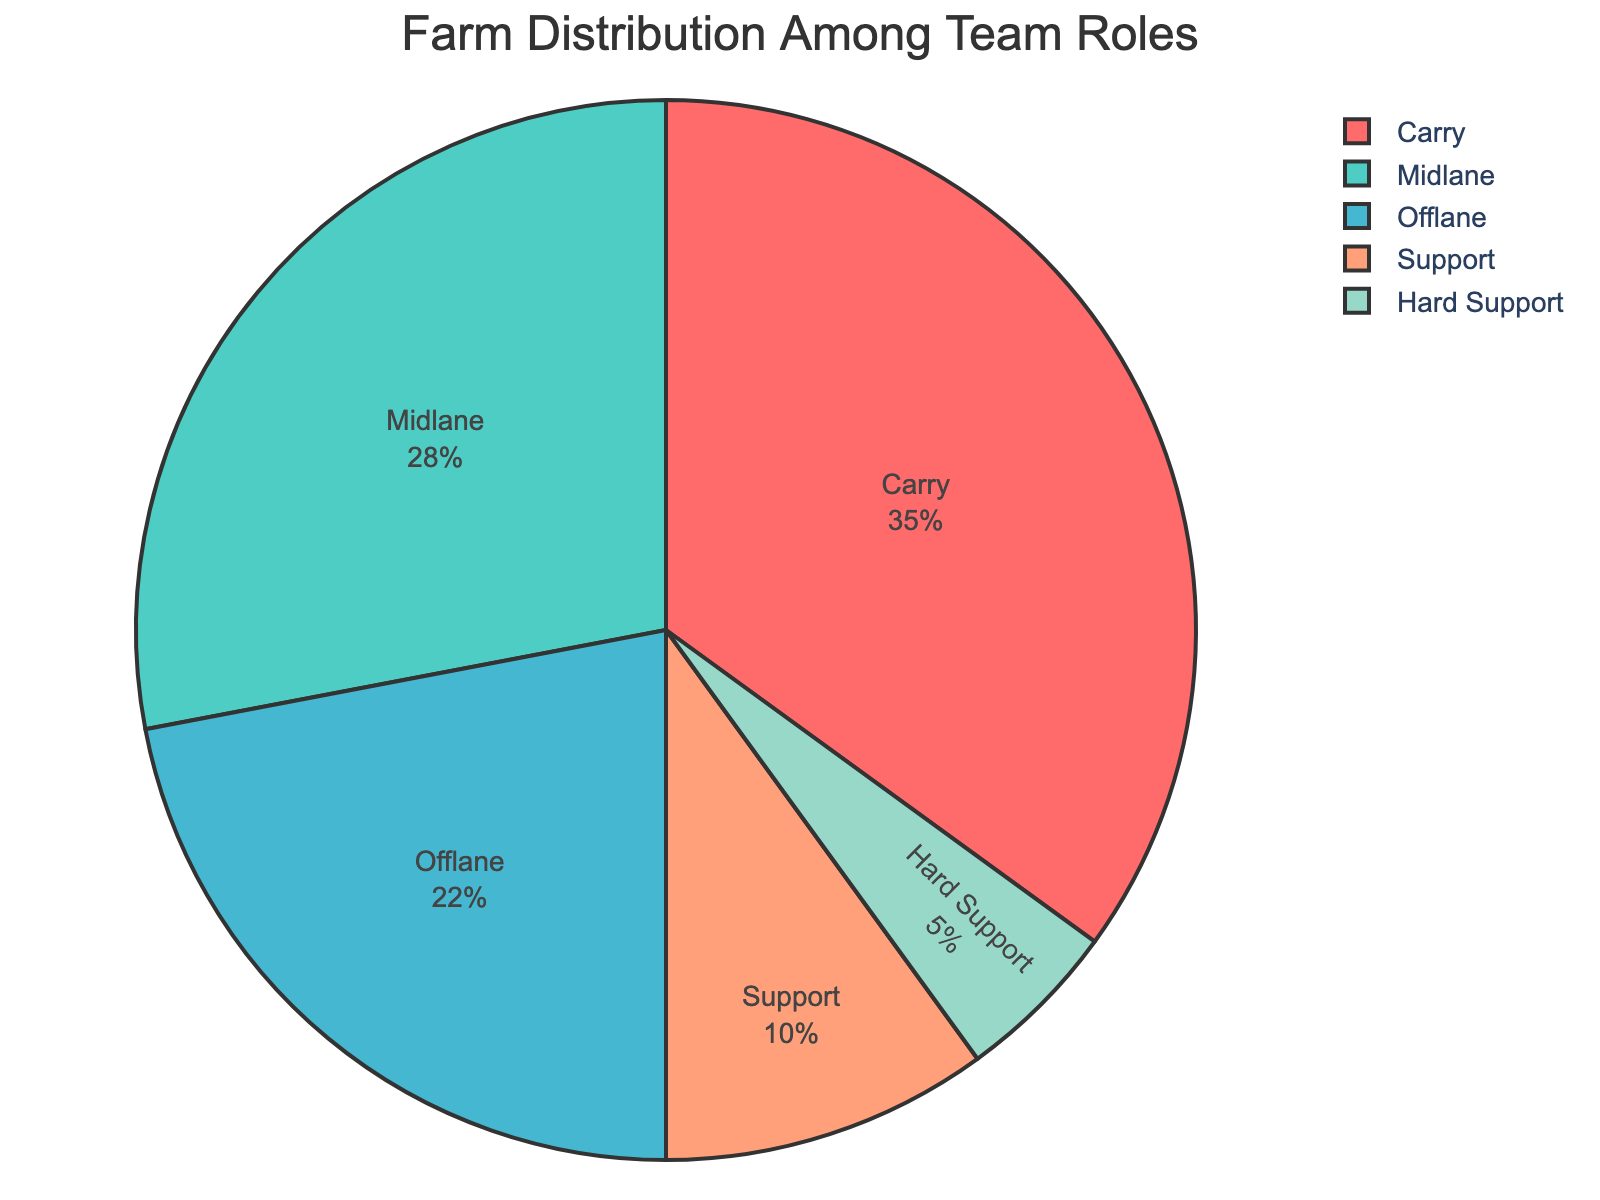What role has the highest farm percentage? By visually inspecting the pie chart, we can see the largest sector corresponds to the role with the highest farm percentage.
Answer: Carry How much more farm percentage does the Carry have compared to the Midlane? The Carry has 35% and the Midlane has 28%. Subtracting these values gives 35% - 28% = 7%.
Answer: 7% Which role has the smallest farm percentage? From the chart, the smallest sector, representing the smallest percentage, is the one for the Hard Support role.
Answer: Hard Support What is the combined farm percentage for the Support and Hard Support roles? Add the farm percentages for Support (10%) and Hard Support (5%), giving us 10% + 5% = 15%.
Answer: 15% How does the farm percentage of the Offlane compare to that of the Support? The Offlane farm percentage is 22% and the Support farm percentage is 10%. So, the Offlane has a higher farm percentage (22% > 10%).
Answer: Offlane has more What role represents the medium-sized sector in the pie chart? Observing the pie chart, the sector representing the Midlane role is medium-sized compared to others.
Answer: Midlane What is the total farm percentage for all roles other than Carry? Subtract the Carry's percentage (35%) from the total (100%), giving 100% - 35% = 65%.
Answer: 65% Is the Offlane farm percentage greater than the Midlane farm percentage? Comparing the percentages, Offlane has 22% while Midlane has 28%, so Offlane's farm percentage is not greater than Midlane's.
Answer: No What is the average farm percentage of the Offlane, Support, and Hard Support roles? Add the percentages of Offlane (22%), Support (10%), and Hard Support (5%) to get 22% + 10% + 5% = 37%, then divide by 3, which gives 37% / 3 ≈ 12.33%.
Answer: 12.33% Which role has a farm percentage closest to a quarter (25%) of the total farm percentage? By checking the closest values in the pie chart, the Midlane farm percentage at 28% is nearest to 25%.
Answer: Midlane 